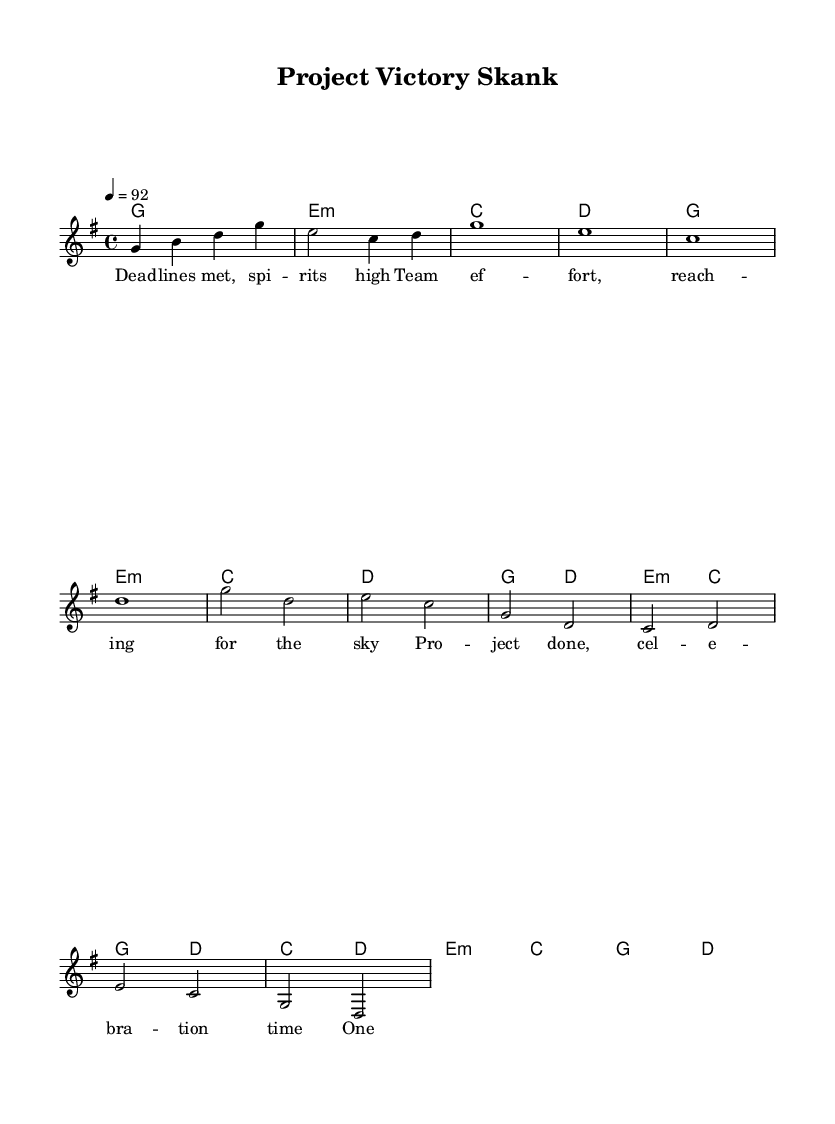What is the key signature of this music? The key signature is G major, which has one sharp (F#). This can be identified by looking at the key signature located at the beginning of the staff.
Answer: G major What is the time signature of this music? The time signature is 4/4, indicating that there are four beats in each measure and the quarter note receives one beat. This is typically located at the beginning of the piece, often next to the key signature.
Answer: 4/4 What is the tempo marking of this piece? The tempo marking is quarter note = 92, which specifies the speed of the music. This indicates that each quarter note should be played at a speed of 92 beats per minute.
Answer: 92 How many measures are in the chorus section? The chorus section consists of 4 measures, which can be counted by identifying the different phrases labeled in the music. Each measure is separated by vertical bar lines, and the chorus is distinctly marked to identify its section.
Answer: 4 What are the primary themes reflected in the lyrics? The primary themes are teamwork and celebration. The lyrics emphasize unity and the positive feeling after completing a project, which is a common theme in reggae music that promotes togetherness and joy.
Answer: Teamwork and celebration What chord appears most frequently throughout the song? The G major chord appears most frequently throughout the song. By analyzing the chords listed in the chord section, we can see that G major is represented in both the verses and the chorus multiple times.
Answer: G major What is the overall mood conveyed by the music and lyrics? The overall mood is celebratory and uplifting. The combination of the reggae style and the lyrics that talk about success and teamwork contribute to a joyful and positive atmosphere.
Answer: Celebratory and uplifting 